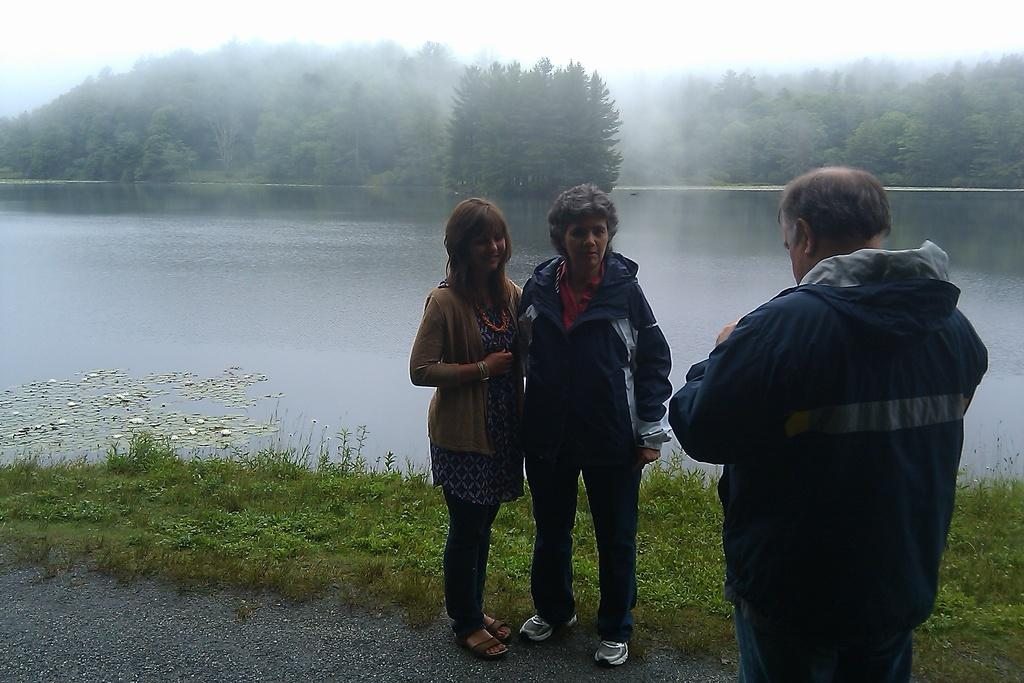How many people are in the image? There are two women and a man in the image. What is the surface they are standing on? They are standing on the ground. What can be seen in the background of the image? There is grass, water, trees, and the sky visible in the background. What type of plate is being used to generate steam in the image? There is no plate or steam present in the image. How does friction affect the movement of the trees in the image? There is no mention of friction or movement of trees in the image; the trees are stationary in the background. 